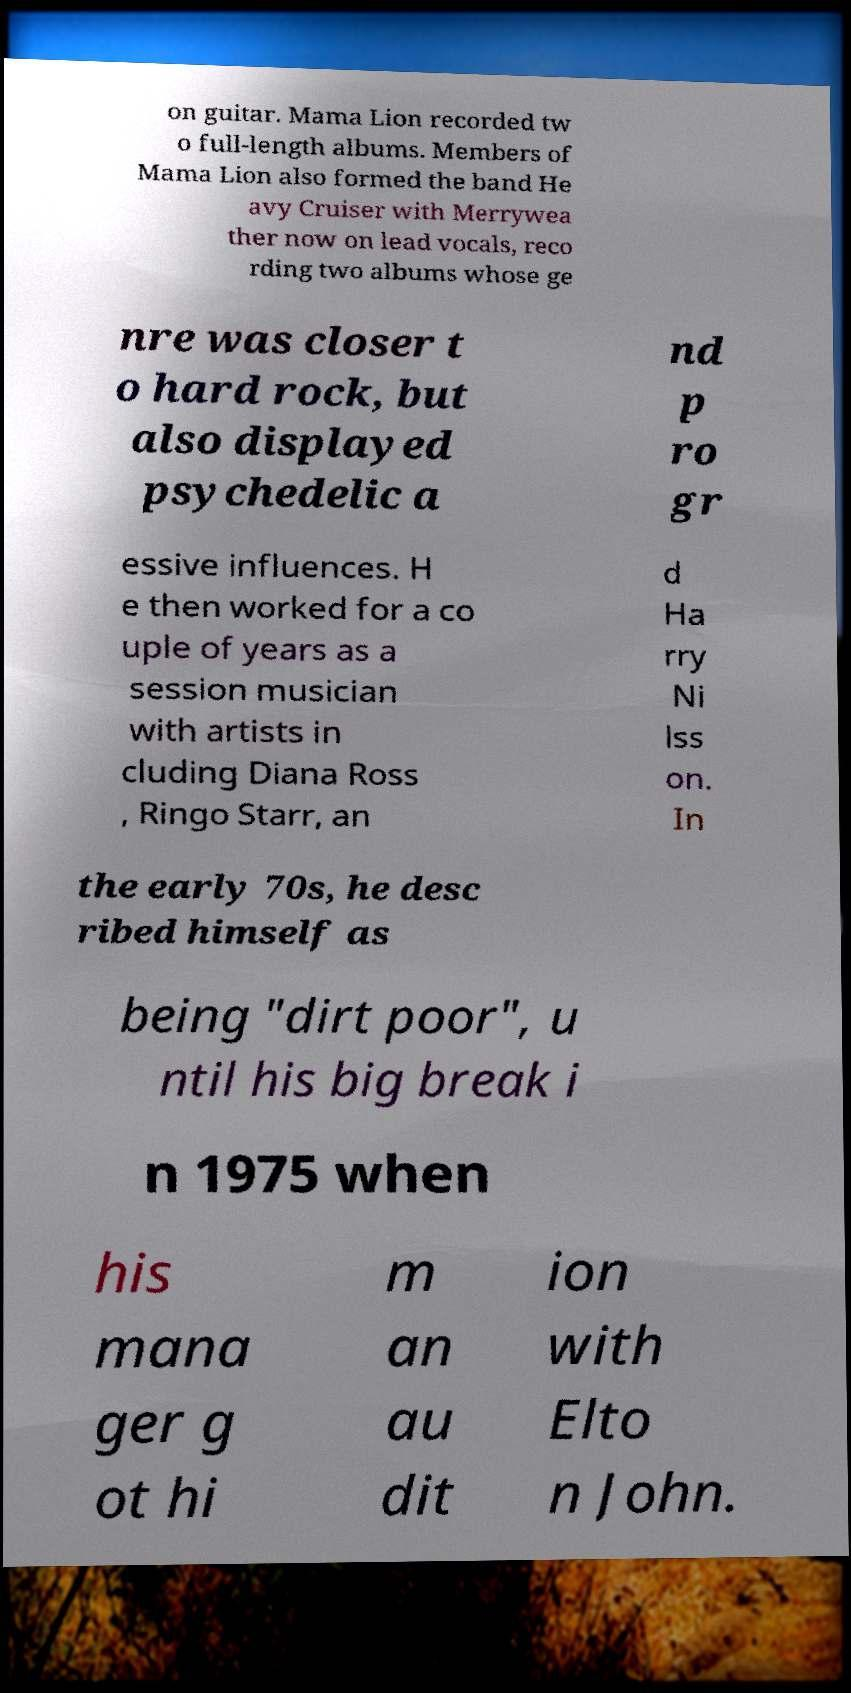What messages or text are displayed in this image? I need them in a readable, typed format. on guitar. Mama Lion recorded tw o full-length albums. Members of Mama Lion also formed the band He avy Cruiser with Merrywea ther now on lead vocals, reco rding two albums whose ge nre was closer t o hard rock, but also displayed psychedelic a nd p ro gr essive influences. H e then worked for a co uple of years as a session musician with artists in cluding Diana Ross , Ringo Starr, an d Ha rry Ni lss on. In the early 70s, he desc ribed himself as being "dirt poor", u ntil his big break i n 1975 when his mana ger g ot hi m an au dit ion with Elto n John. 